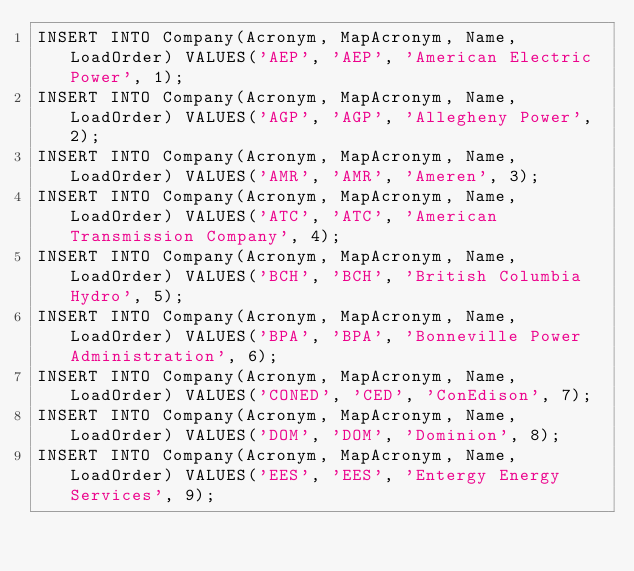Convert code to text. <code><loc_0><loc_0><loc_500><loc_500><_SQL_>INSERT INTO Company(Acronym, MapAcronym, Name, LoadOrder) VALUES('AEP', 'AEP', 'American Electric Power', 1);
INSERT INTO Company(Acronym, MapAcronym, Name, LoadOrder) VALUES('AGP', 'AGP', 'Allegheny Power', 2);
INSERT INTO Company(Acronym, MapAcronym, Name, LoadOrder) VALUES('AMR', 'AMR', 'Ameren', 3);
INSERT INTO Company(Acronym, MapAcronym, Name, LoadOrder) VALUES('ATC', 'ATC', 'American Transmission Company', 4);
INSERT INTO Company(Acronym, MapAcronym, Name, LoadOrder) VALUES('BCH', 'BCH', 'British Columbia Hydro', 5);
INSERT INTO Company(Acronym, MapAcronym, Name, LoadOrder) VALUES('BPA', 'BPA', 'Bonneville Power Administration', 6);
INSERT INTO Company(Acronym, MapAcronym, Name, LoadOrder) VALUES('CONED', 'CED', 'ConEdison', 7);
INSERT INTO Company(Acronym, MapAcronym, Name, LoadOrder) VALUES('DOM', 'DOM', 'Dominion', 8);
INSERT INTO Company(Acronym, MapAcronym, Name, LoadOrder) VALUES('EES', 'EES', 'Entergy Energy Services', 9);</code> 